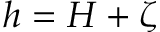Convert formula to latex. <formula><loc_0><loc_0><loc_500><loc_500>h = H + \zeta</formula> 